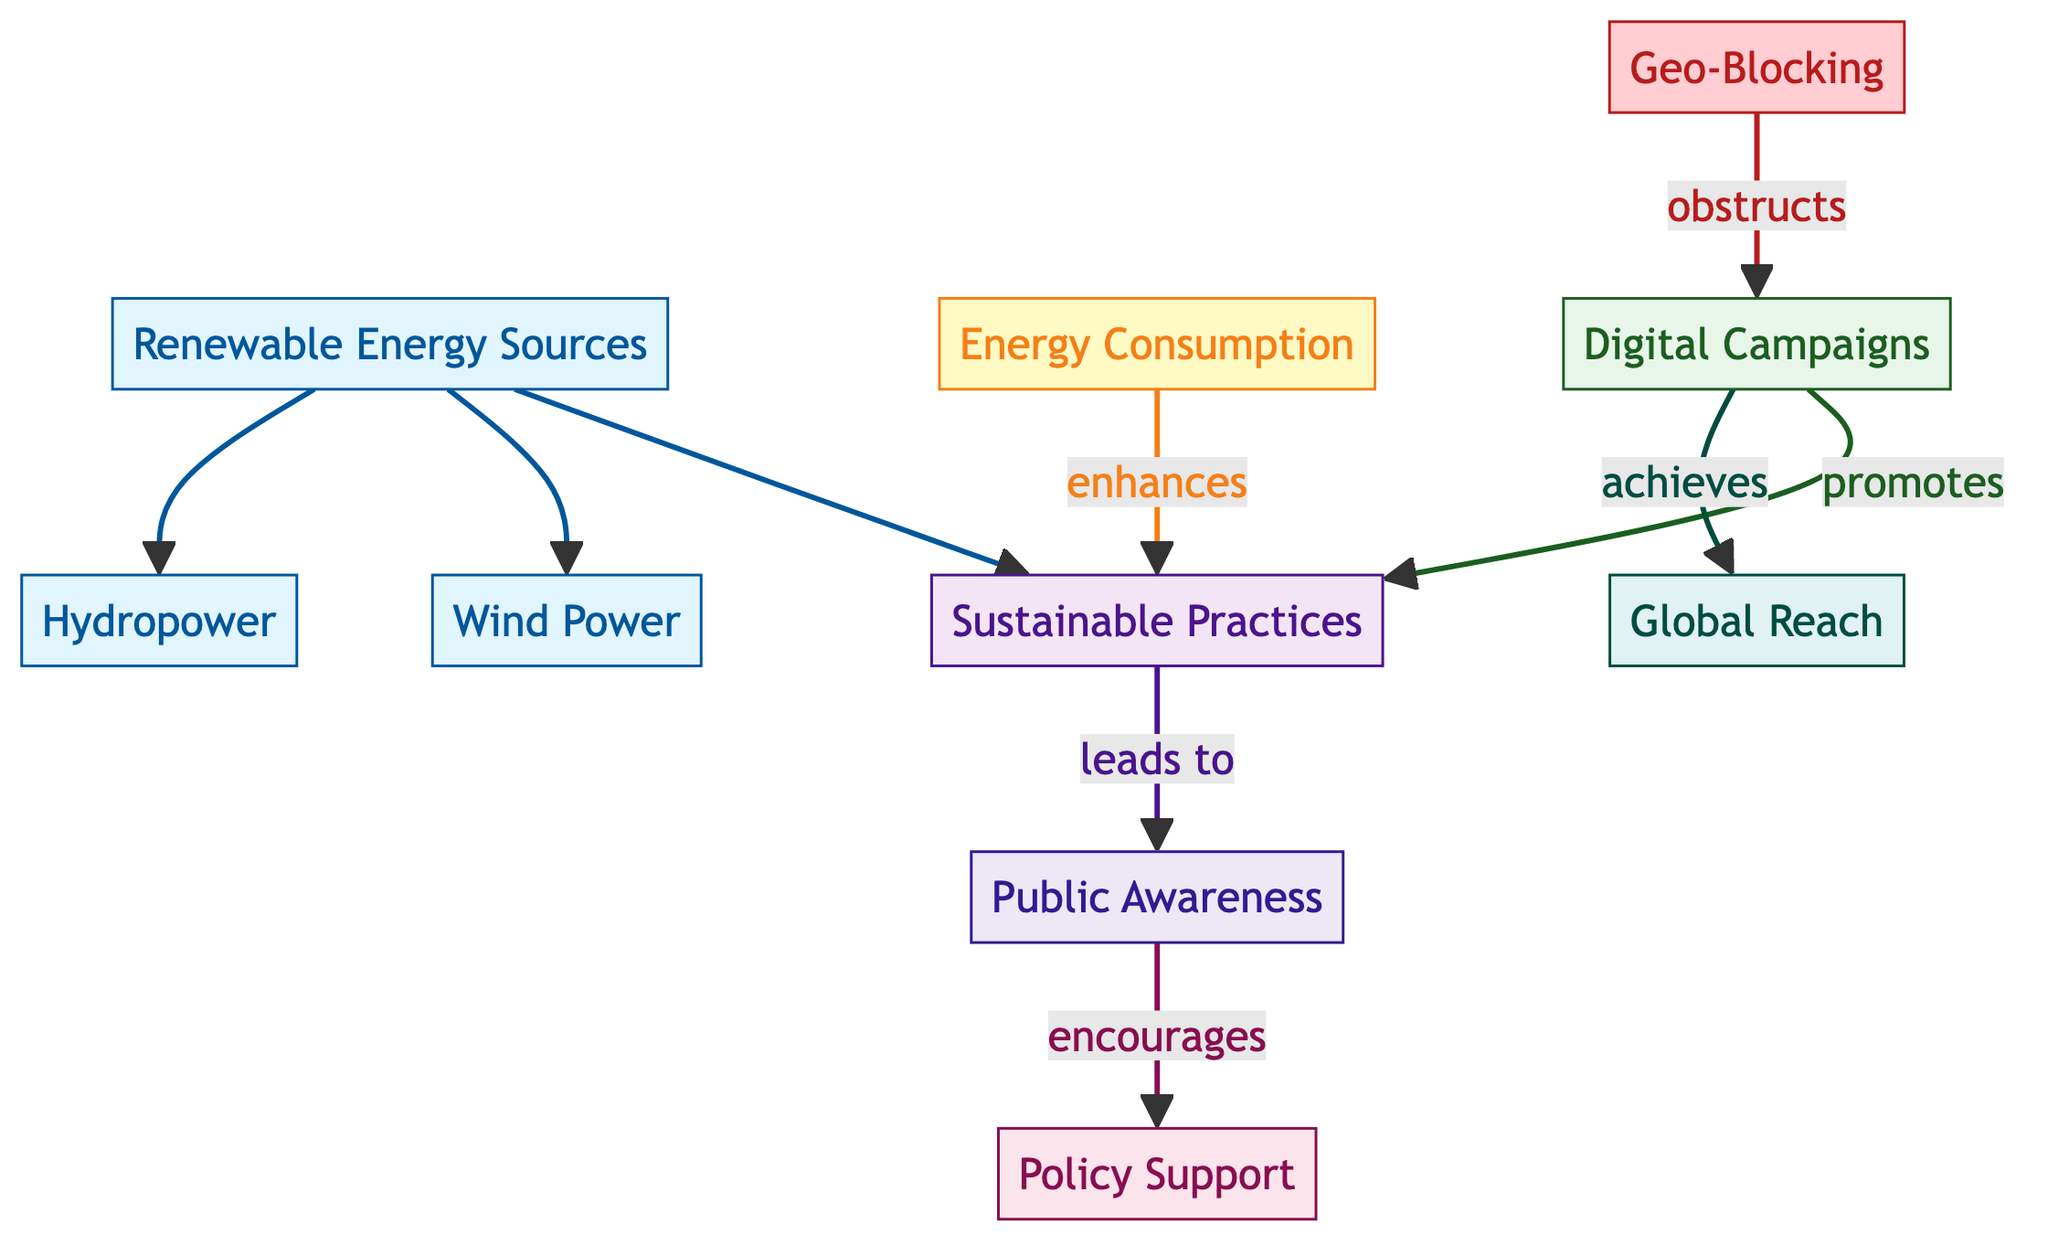What is the primary focus of the diagram? The diagram centers on the relationships between energy resources, barriers like geo-blocking, digital campaigns, and sustainable practices. It outlines how these elements interact to promote awareness and policy support for energy consumption.
Answer: Energy Resource Distribution and Consumption How many energy resources are illustrated in the diagram? There are three main renewable energy sources depicted: solar power, wind power, and hydropower. These nodes are connected under the renewable energy sources label.
Answer: Three What does geo-blocking obstruct in the diagram? Geo-blocking impedes digital campaigns, as indicated by the directed line labeled "obstructs" that connects geo-blocking to digital campaigns.
Answer: Digital Campaigns What is promoted through digital campaigns according to the diagram? The diagram explicitly states that digital campaigns promote sustainable practices, indicated by the arrow that leads from digital campaigns to sustainable practices.
Answer: Sustainable Practices How does energy consumption enhance sustainable practices? The connection between energy consumption and sustainable practices is indicated as an enhancing relationship, showing that increasing energy consumption contributes to sustainability.
Answer: Enhances What outcome results from public awareness? Public awareness leads to policy support, as shown by the arrow from public awareness to policy support in the diagram.
Answer: Policy Support How does geo-blocking indirectly influence global reach? Geo-blocking indirectly affects global reach by obstructing digital campaigns, which are necessary for achieving a broader global reach. Therefore, it creates a barrier to successful outreach.
Answer: Global Reach Which energy source is not included as a direct node in the diagram? The diagram does not include fossil fuels or non-renewable sources among the energy resources, indicating an exclusive focus on renewable energy alternatives.
Answer: Fossil Fuels What color coding represents barriers in the diagram? The barriers are represented using a specific color scheme defined in the diagram: barriers are colored in a shade of pink to distinguish them from other elements.
Answer: Pink 